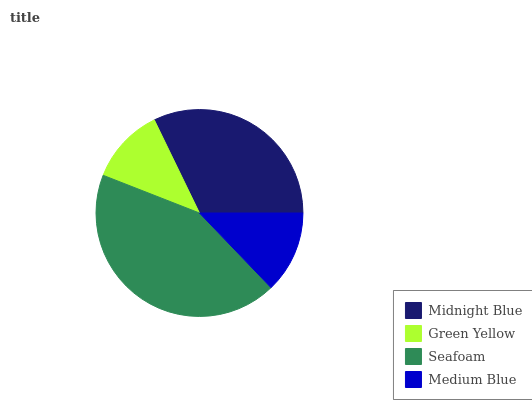Is Green Yellow the minimum?
Answer yes or no. Yes. Is Seafoam the maximum?
Answer yes or no. Yes. Is Seafoam the minimum?
Answer yes or no. No. Is Green Yellow the maximum?
Answer yes or no. No. Is Seafoam greater than Green Yellow?
Answer yes or no. Yes. Is Green Yellow less than Seafoam?
Answer yes or no. Yes. Is Green Yellow greater than Seafoam?
Answer yes or no. No. Is Seafoam less than Green Yellow?
Answer yes or no. No. Is Midnight Blue the high median?
Answer yes or no. Yes. Is Medium Blue the low median?
Answer yes or no. Yes. Is Medium Blue the high median?
Answer yes or no. No. Is Green Yellow the low median?
Answer yes or no. No. 